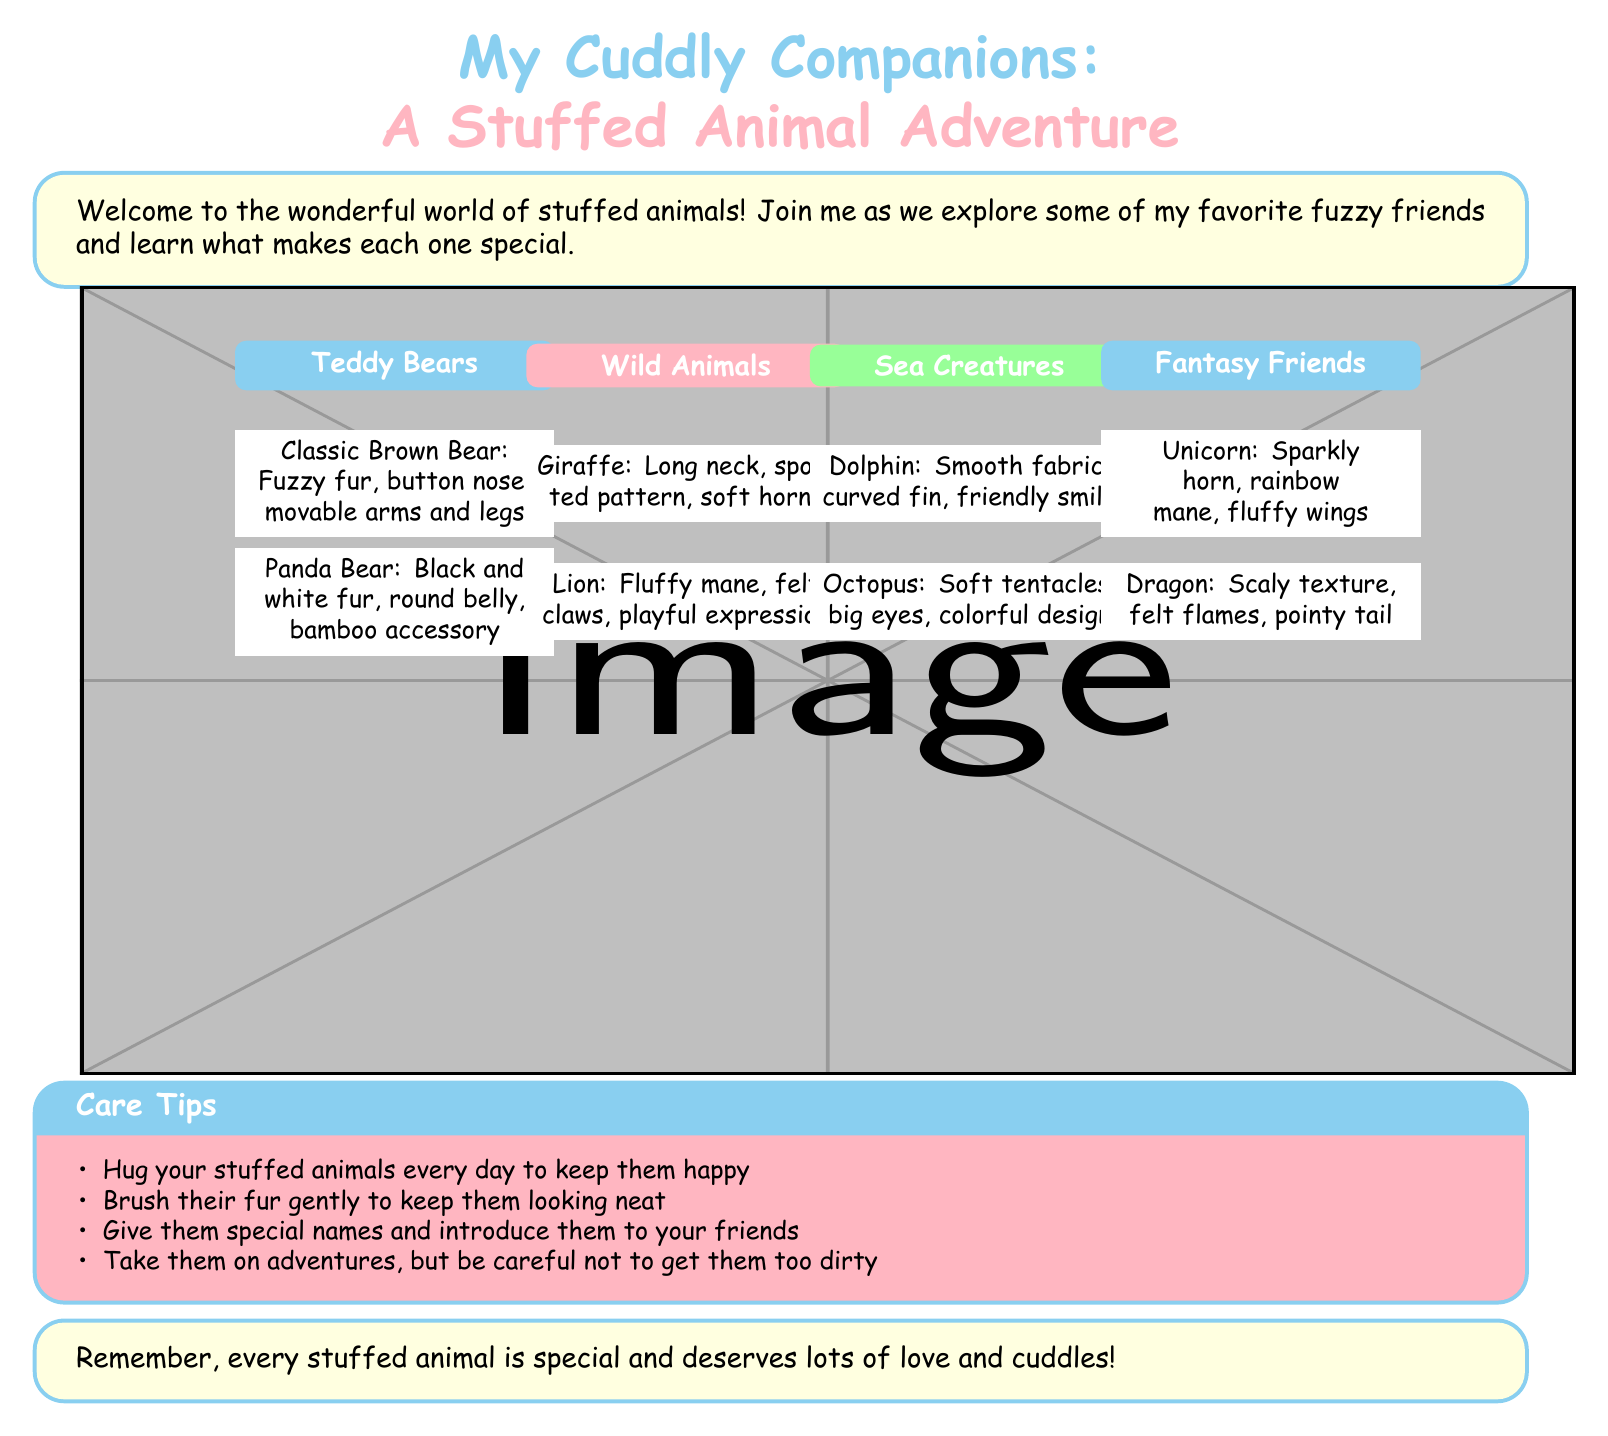What is the title of the catalog? The title is prominently displayed at the top of the document.
Answer: My Cuddly Companions: A Stuffed Animal Adventure How many types of teddy bears are mentioned? The document lists two specific types of teddy bears.
Answer: 2 What color is the panda bear's fur? The panda bear is described with a specific color in the document.
Answer: Black and white Name one of the sea creatures featured in the catalog. The document lists two sea creatures, so any of them could be the answer.
Answer: Dolphin What special feature does the unicorn have? The unicorn is described with a specific feature that sets it apart.
Answer: Sparkly horn How many wild animals are mentioned? The document lists two distinct wild animals.
Answer: 2 What care tip suggests you should hug your stuffed animals? The document includes care tips for keeping stuffed animals happy.
Answer: Hug your stuffed animals every day to keep them happy Which section features fantasy friends? The section that highlights fantasy friends has a specific title.
Answer: Fantasy Friends 